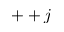Convert formula to latex. <formula><loc_0><loc_0><loc_500><loc_500>+ + j</formula> 